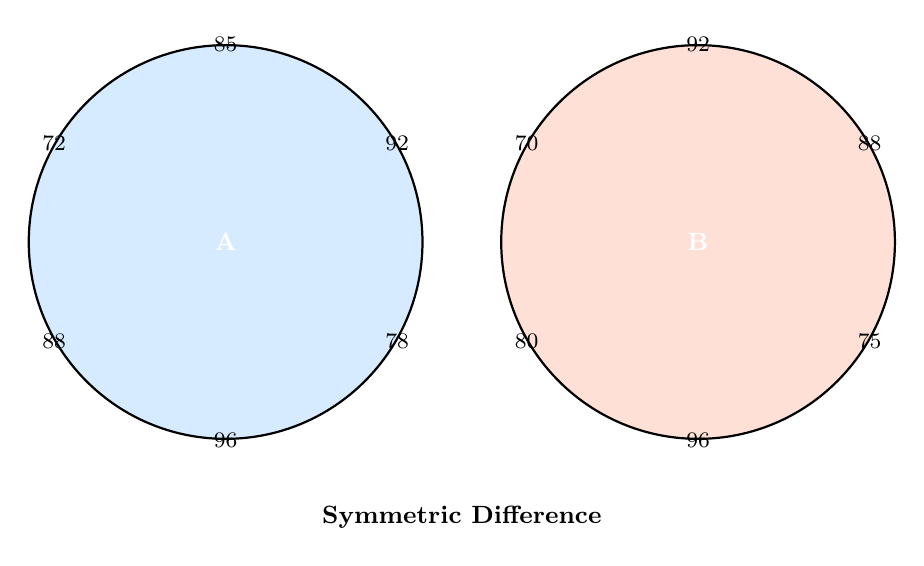Help me with this question. To solve this problem, we need to follow these steps:

1) Recall the definition of symmetric difference:
   The symmetric difference of two sets A and B, denoted by $A \triangle B$, is the set of elements that are in either A or B, but not in both.

2) Mathematically, this can be expressed as:
   $A \triangle B = (A \setminus B) \cup (B \setminus A)$

3) Let's identify the elements unique to each set:
   - Elements in A but not in B: {85, 78, 72}
   - Elements in B but not in A: {75, 80, 70}

4) The symmetric difference is the union of these:
   $A \triangle B = \{85, 78, 72, 75, 80, 70\}$

5) To find the sum of elements in the symmetric difference:
   $85 + 78 + 72 + 75 + 80 + 70 = 460$

Therefore, the sum of the elements in the symmetric difference is 460.
Answer: 460 